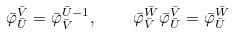Convert formula to latex. <formula><loc_0><loc_0><loc_500><loc_500>\bar { \varphi } _ { \bar { U } } ^ { \bar { V } } = \bar { \varphi } ^ { \bar { U } - 1 } _ { \bar { V } } , \quad \bar { \varphi } _ { \bar { V } } ^ { \bar { W } } \bar { \varphi } _ { \bar { U } } ^ { \bar { V } } = \bar { \varphi } _ { \bar { U } } ^ { \bar { W } }</formula> 